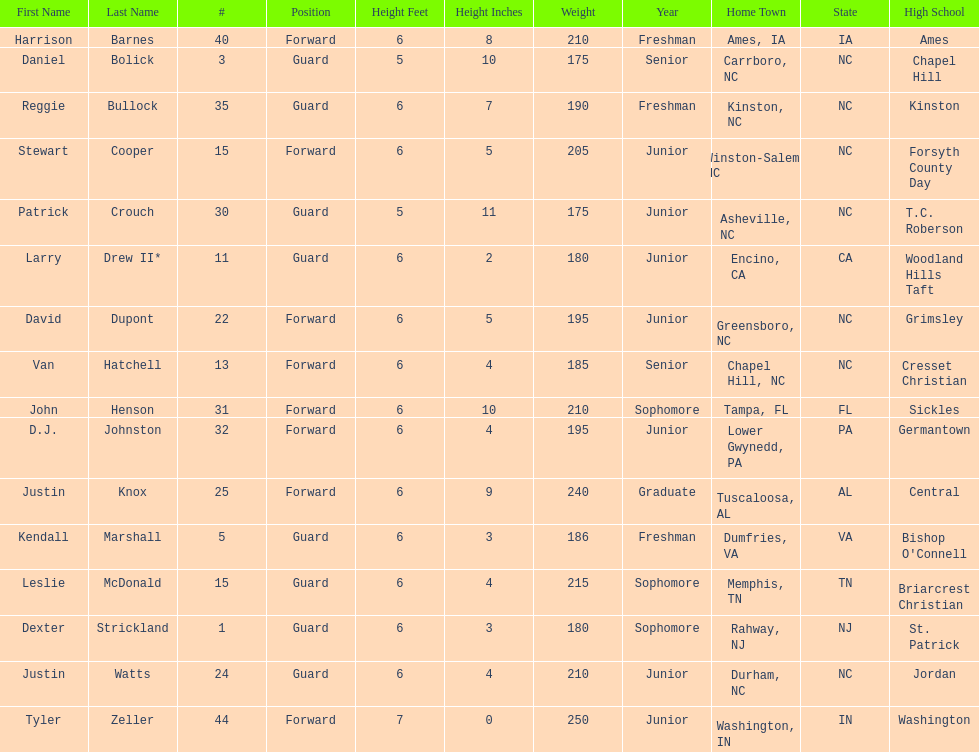Write the full table. {'header': ['First Name', 'Last Name', '#', 'Position', 'Height Feet', 'Height Inches', 'Weight', 'Year', 'Home Town', 'State', 'High School'], 'rows': [['Harrison', 'Barnes', '40', 'Forward', '6', '8', '210', 'Freshman', 'Ames, IA', 'IA', 'Ames'], ['Daniel', 'Bolick', '3', 'Guard', '5', '10', '175', 'Senior', 'Carrboro, NC', 'NC', 'Chapel Hill'], ['Reggie', 'Bullock', '35', 'Guard', '6', '7', '190', 'Freshman', 'Kinston, NC', 'NC', 'Kinston'], ['Stewart', 'Cooper', '15', 'Forward', '6', '5', '205', 'Junior', 'Winston-Salem, NC', 'NC', 'Forsyth County Day'], ['Patrick', 'Crouch', '30', 'Guard', '5', '11', '175', 'Junior', 'Asheville, NC', 'NC', 'T.C. Roberson'], ['Larry', 'Drew II*', '11', 'Guard', '6', '2', '180', 'Junior', 'Encino, CA', 'CA', 'Woodland Hills Taft'], ['David', 'Dupont', '22', 'Forward', '6', '5', '195', 'Junior', 'Greensboro, NC', 'NC', 'Grimsley'], ['Van', 'Hatchell', '13', 'Forward', '6', '4', '185', 'Senior', 'Chapel Hill, NC', 'NC', 'Cresset Christian'], ['John', 'Henson', '31', 'Forward', '6', '10', '210', 'Sophomore', 'Tampa, FL', 'FL', 'Sickles'], ['D.J.', 'Johnston', '32', 'Forward', '6', '4', '195', 'Junior', 'Lower Gwynedd, PA', 'PA', 'Germantown'], ['Justin', 'Knox', '25', 'Forward', '6', '9', '240', 'Graduate', 'Tuscaloosa, AL', 'AL', 'Central'], ['Kendall', 'Marshall', '5', 'Guard', '6', '3', '186', 'Freshman', 'Dumfries, VA', 'VA', "Bishop O'Connell"], ['Leslie', 'McDonald', '15', 'Guard', '6', '4', '215', 'Sophomore', 'Memphis, TN', 'TN', 'Briarcrest Christian'], ['Dexter', 'Strickland', '1', 'Guard', '6', '3', '180', 'Sophomore', 'Rahway, NJ', 'NJ', 'St. Patrick'], ['Justin', 'Watts', '24', 'Guard', '6', '4', '210', 'Junior', 'Durham, NC', 'NC', 'Jordan'], ['Tyler', 'Zeller', '44', 'Forward', '7', '0', '250', 'Junior', 'Washington, IN', 'IN', 'Washington']]} What is the number of players with a weight over 200? 7. 